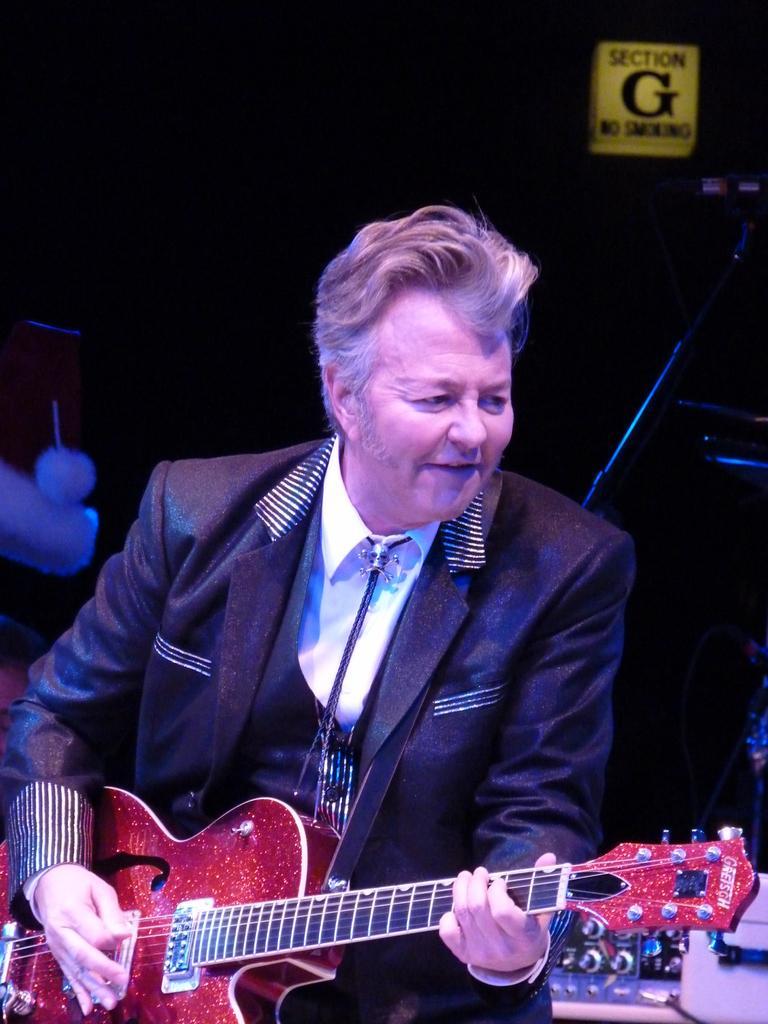Describe this image in one or two sentences. In this picture we can see man holding guitar in his hand and playing and smiling and in background it is dark. 